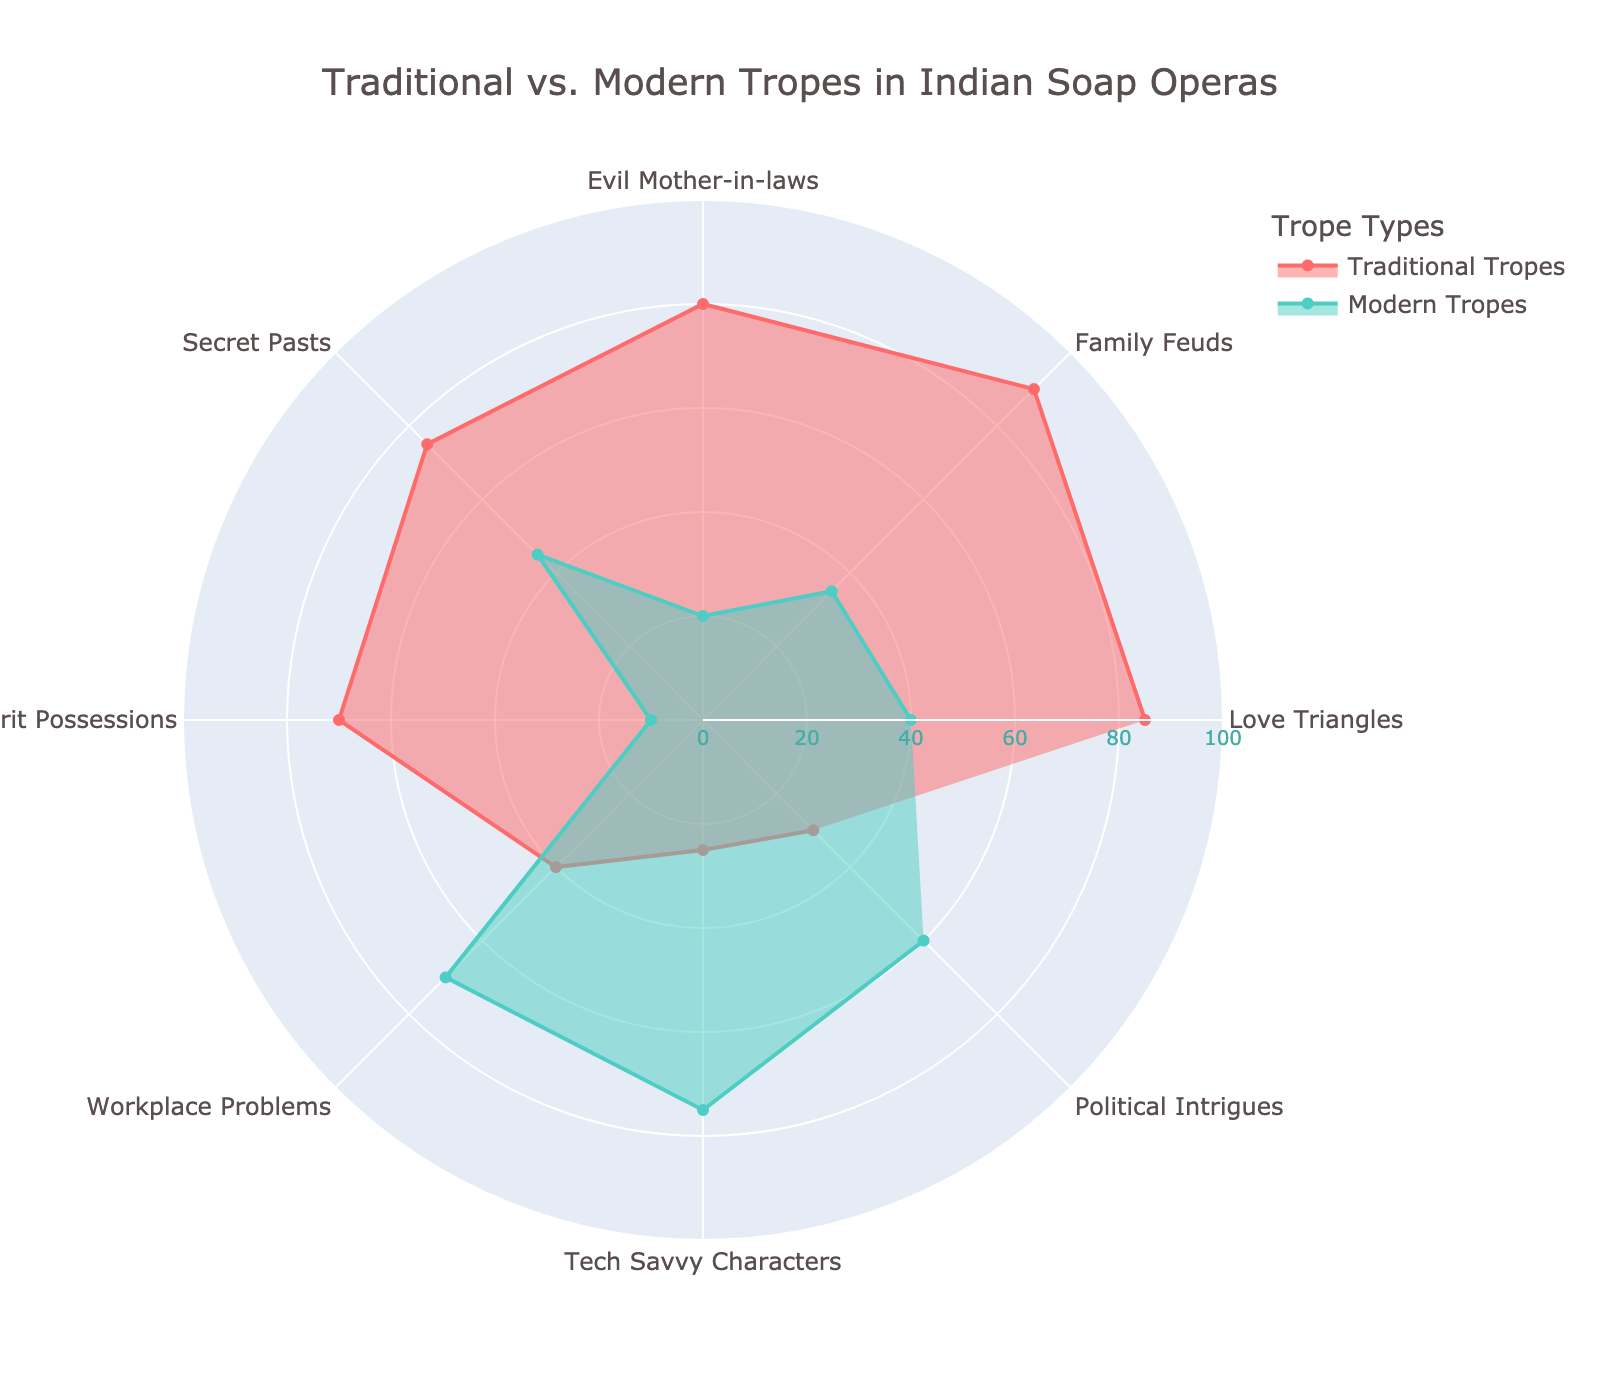What is the title of the radar chart? The title of the radar chart is displayed prominently at the top, summarizing the overall theme of the chart.
Answer: Traditional vs. Modern Tropes in Indian Soap Operas Which category has the highest value for Traditional Tropes? Looking at the radar chart, observe which category reaches the furthest out toward the edge of the chart for the Traditional Tropes.
Answer: Family Feuds How does the value for Family Feuds in Traditional Tropes compare to its value in Modern Tropes? Identify the values for Family Feuds in both Traditional and Modern Tropes and compare them numerically. The Traditional value is significantly higher than the Modern value.
Answer: 90 vs. 35 What is the average value of Traditional Tropes across all categories? Add all the values of Traditional Tropes (85 + 90 + 80 + 75 + 70 + 40 + 25 + 30) and divide by the number of categories (8).
Answer: 61.875 Which trope category has the smallest difference between Traditional and Modern Tropes? Calculate the difference between Traditional and Modern Tropes for each category and find the smallest difference.
Answer: Secret Pasts (difference = 30) Are there any categories where Modern Tropes have a higher value than Traditional Tropes? If so, name them. Compare the values of Modern Tropes to Traditional Tropes for each category to check if Modern Tropes are higher and list these categories.
Answer: Workplace Problems, Tech Savvy Characters, Political Intrigues What is the range of values for Traditional Tropes? Find the difference between the maximum value (Family Feuds = 90) and the minimum value (Tech Savvy Characters = 25) for Traditional Tropes.
Answer: 65 Compared to Traditional Tropes, how many categories do Modern Tropes score above 50? Count the number of categories where Modern Tropes have values above 50.
Answer: 3 What is the trend observed between Traditional Tropes and Modern Tropes? Analyze the overall pattern where typically, categories with high Traditional Tropes values tend to have lower Modern Tropes values and vice versa.
Answer: Inverse relationship Which trope has the smallest representation in Modern Tropes? Identify the value that is closest to the center of the chart in the Modern Tropes category.
Answer: Spirit Possessions (10) 